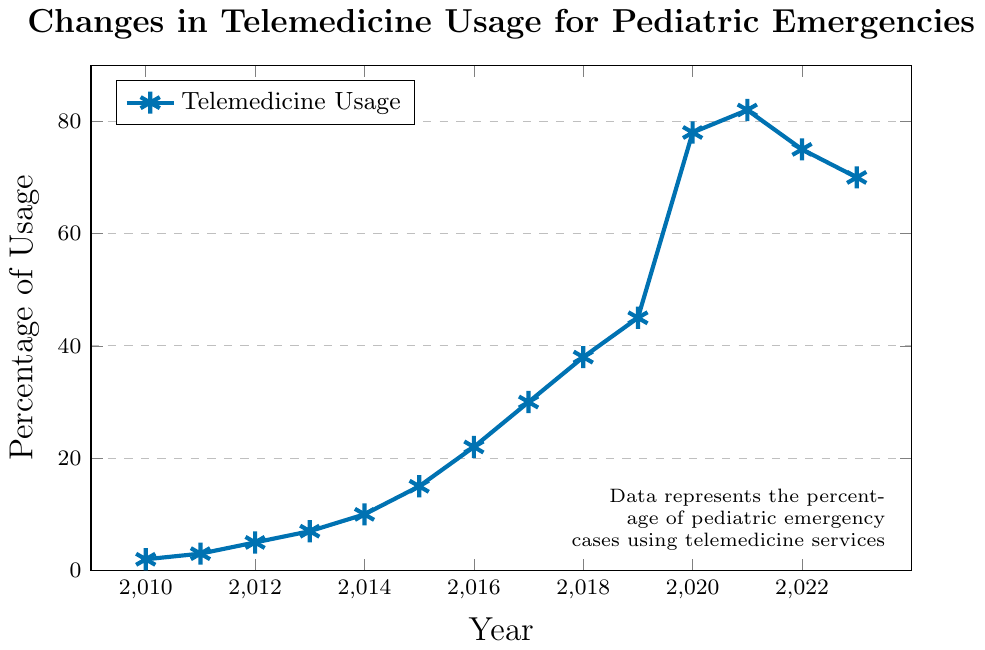What's the percentage of telemedicine usage in 2020? Find the point on the chart corresponding to the year 2020. The percentage value at this point is 78.
Answer: 78 Between which two years did the highest increase in telemedicine usage occur? Identify the steepest slope on the line graph. The highest increase occurs between 2019 and 2020, where the usage jumps from 45 to 78.
Answer: 2019-2020 How much did telemedicine usage increase between 2012 and 2016? Look at the values for 2012 and 2016, which are 5 and 22, respectively. Subtract the earlier value from the later value: 22 - 5 = 17.
Answer: 17 What is the overall trend in telemedicine usage from 2010 to 2023? Observe the general direction of the line from 2010 to 2023. The usage generally increases, peaking in 2021, before decreasing slightly in 2022 and 2023.
Answer: Increasing trend with a peak in 2021 In which year did the usage first exceed 20%? Find the point on the graph where the percentage first goes above 20. This occurs at 2016.
Answer: 2016 How does the usage in 2023 compare to the usage in 2018? Note the values for 2018 and 2023 which are 38 and 70, respectively. 70 is greater than 38, indicating an increase.
Answer: Higher in 2023 By what percentage did the telemedicine usage decrease from 2021 to 2023? Find the values for 2021 and 2023, which are 82 and 70, respectively. Subtract the later value from the earlier value and then divide by the earlier value, multiply by 100: ((82 - 70) / 82) * 100 = 14.63%.
Answer: 14.63% What is the average percentage usage for the years 2010, 2011, and 2012? Sum the values for 2010, 2011, and 2012 (2 + 3 + 5 = 10). Divide this sum by 3 (the number of years): 10 / 3 ≈ 3.33.
Answer: 3.33 What visual attributes indicate a significant change in the figure? Identify the part of the graph where the line shows a steep slope or significant bend. The steep upward slope from 2019 to 2020 indicates a significant change visually.
Answer: Steep upward slope What was the usage of telemedicine in 2015, and how does it compare to the previous year? Find the values for 2015 and 2014, which are 15 and 10, respectively. 15 is greater than 10, indicating an increase.
Answer: 15 and increase 